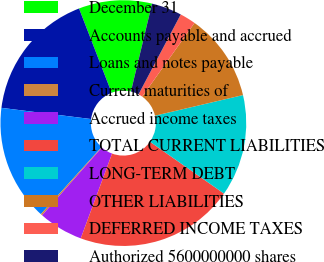<chart> <loc_0><loc_0><loc_500><loc_500><pie_chart><fcel>December 31<fcel>Accounts payable and accrued<fcel>Loans and notes payable<fcel>Current maturities of<fcel>Accrued income taxes<fcel>TOTAL CURRENT LIABILITIES<fcel>LONG-TERM DEBT<fcel>OTHER LIABILITIES<fcel>DEFERRED INCOME TAXES<fcel>Authorized 5600000000 shares<nl><fcel>9.62%<fcel>17.14%<fcel>15.26%<fcel>0.22%<fcel>5.86%<fcel>20.9%<fcel>13.38%<fcel>11.5%<fcel>2.1%<fcel>3.98%<nl></chart> 